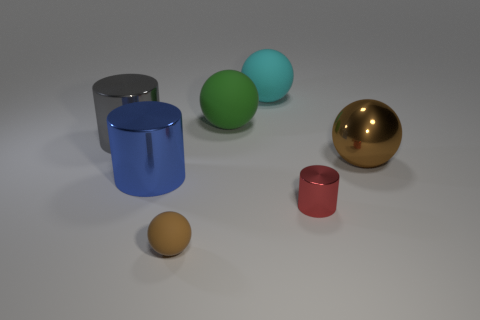There is a metallic cylinder behind the large sphere in front of the big cylinder that is on the left side of the blue cylinder; what size is it?
Ensure brevity in your answer.  Large. What number of other things are there of the same color as the large shiny sphere?
Make the answer very short. 1. What shape is the brown shiny thing that is the same size as the green rubber sphere?
Provide a short and direct response. Sphere. What size is the brown thing that is behind the tiny matte thing?
Your response must be concise. Large. Do the large shiny object that is right of the small cylinder and the cylinder that is behind the big blue shiny thing have the same color?
Ensure brevity in your answer.  No. What is the large object that is on the right side of the tiny red cylinder in front of the big ball to the right of the cyan rubber sphere made of?
Give a very brief answer. Metal. Is there a green ball of the same size as the gray metallic object?
Provide a succinct answer. Yes. There is a gray cylinder that is the same size as the green object; what material is it?
Provide a succinct answer. Metal. What is the shape of the large metallic thing behind the big brown metallic sphere?
Your answer should be compact. Cylinder. Is the small thing to the right of the small rubber object made of the same material as the big sphere that is in front of the gray object?
Your answer should be compact. Yes. 